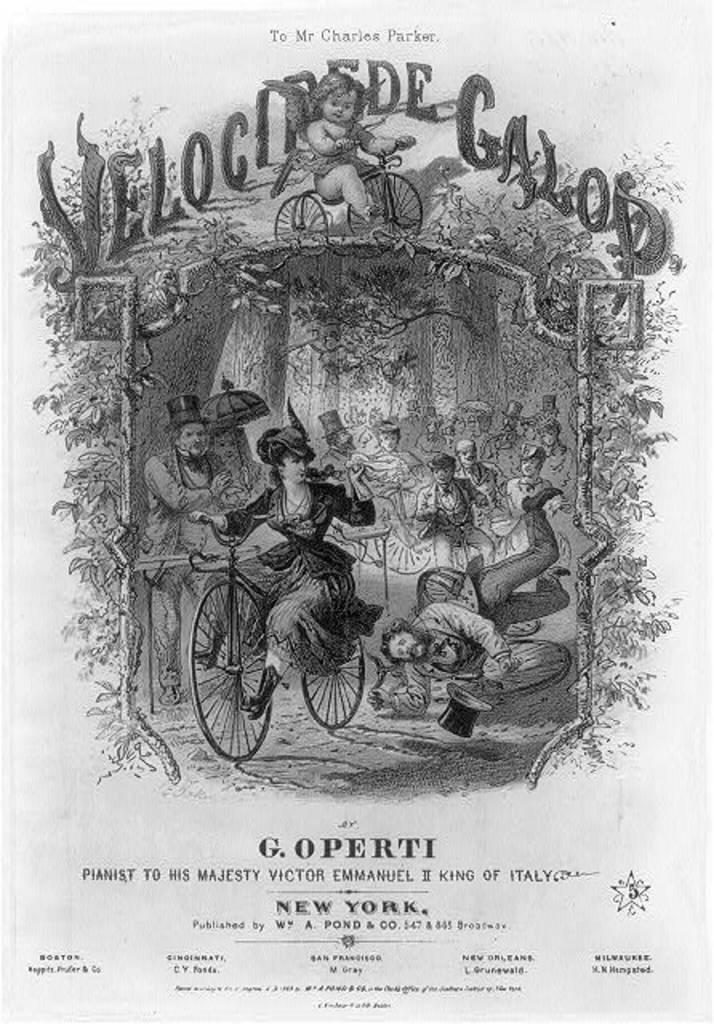What can be found on the top and bottom of the poster? There is text on the top and bottom of the poster. What is happening in the foreground of the image? There is a woman riding a bicycle in the foreground. What type of vegetation is visible in the background? There are trees in the background. Are there any people in the image besides the woman on the bicycle? Yes, there are persons in the background. Can you tell me how many monkeys are swinging from the trees in the background? There are no monkeys present in the image; it features a woman riding a bicycle and persons in the background. What type of oil is being used to lubricate the bicycle chain in the image? There is no mention of oil or any bicycle maintenance in the image; it simply shows a woman riding a bicycle. 